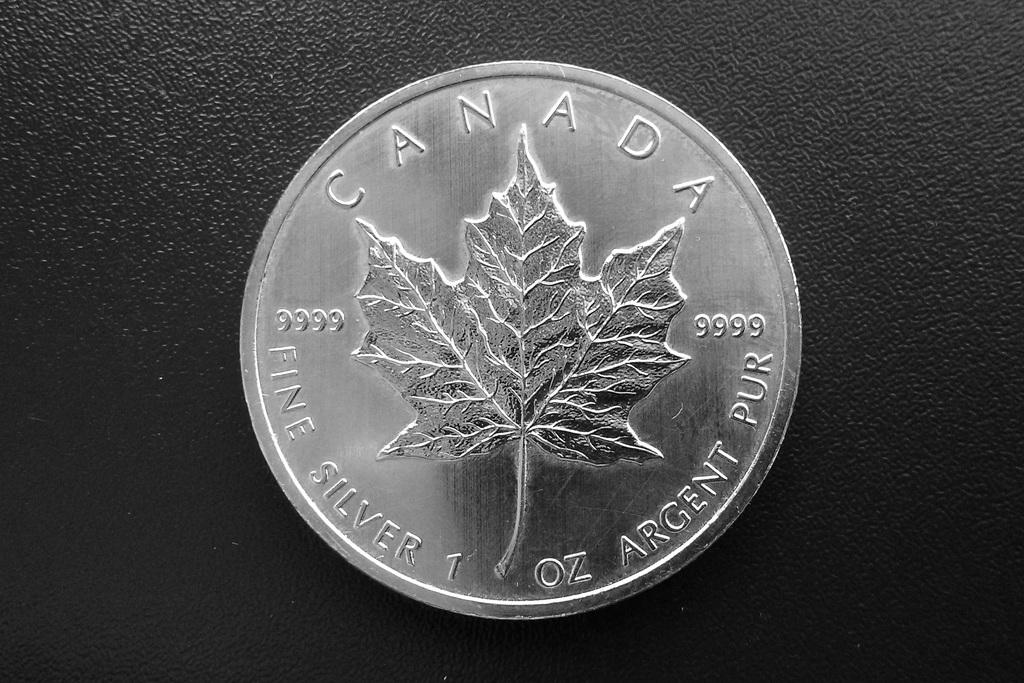<image>
Describe the image concisely. A Canadian coin from Canada currency is displayed with a leaf on it 